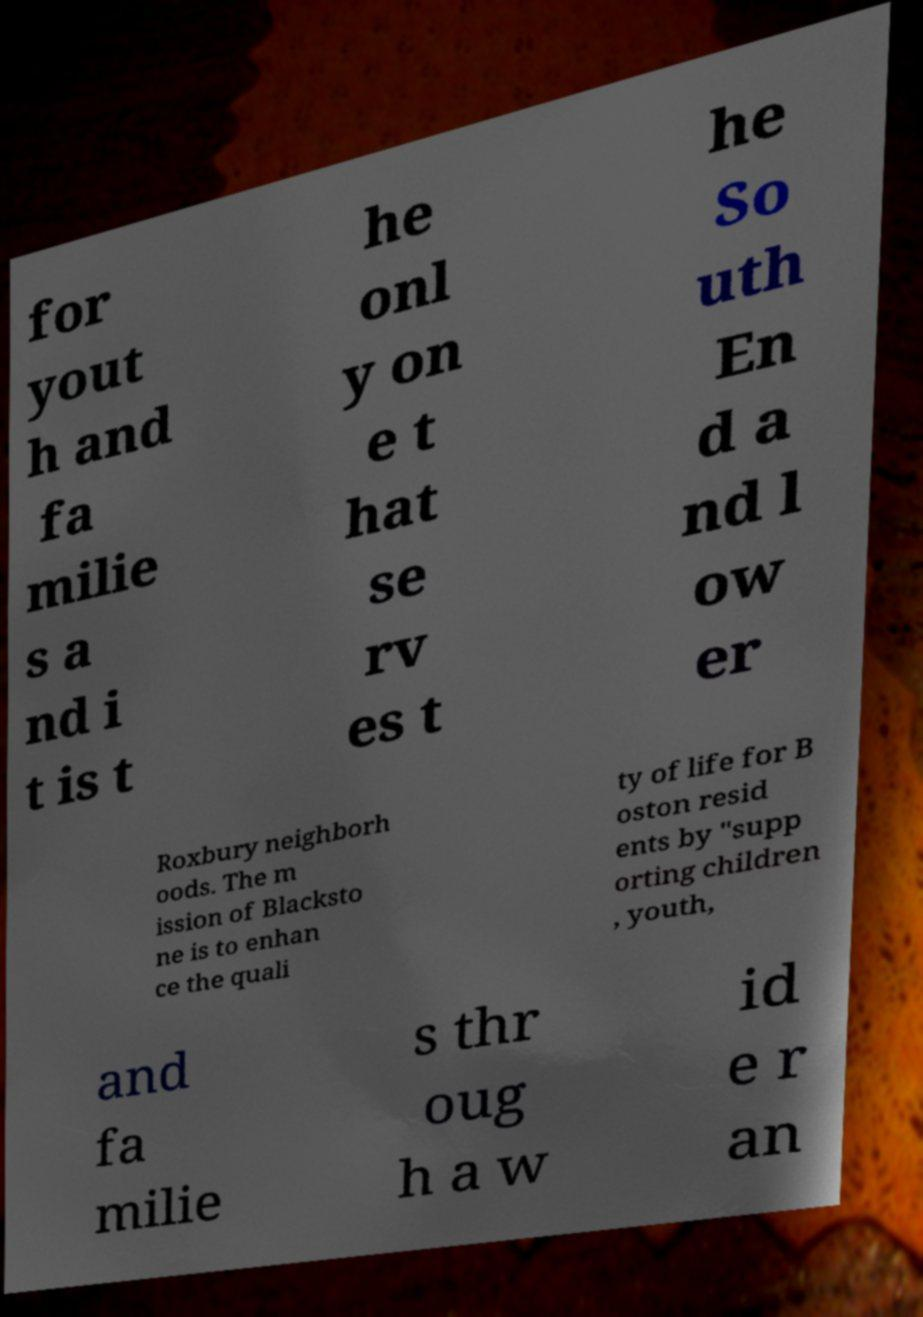Could you extract and type out the text from this image? for yout h and fa milie s a nd i t is t he onl y on e t hat se rv es t he So uth En d a nd l ow er Roxbury neighborh oods. The m ission of Blacksto ne is to enhan ce the quali ty of life for B oston resid ents by "supp orting children , youth, and fa milie s thr oug h a w id e r an 